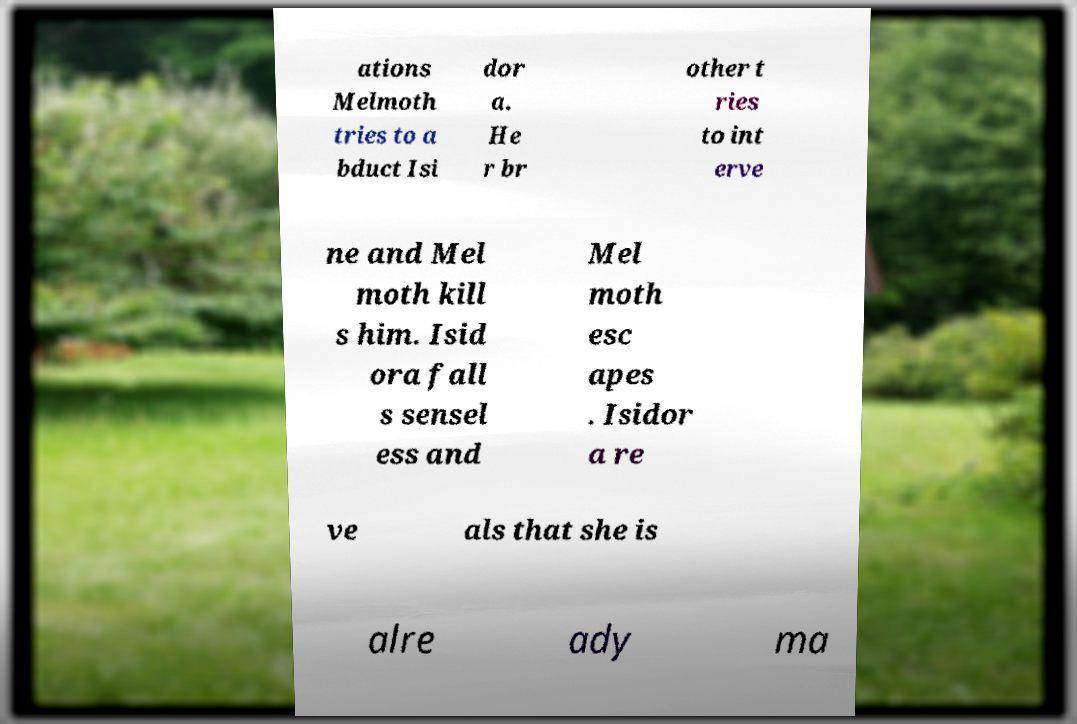Could you extract and type out the text from this image? ations Melmoth tries to a bduct Isi dor a. He r br other t ries to int erve ne and Mel moth kill s him. Isid ora fall s sensel ess and Mel moth esc apes . Isidor a re ve als that she is alre ady ma 